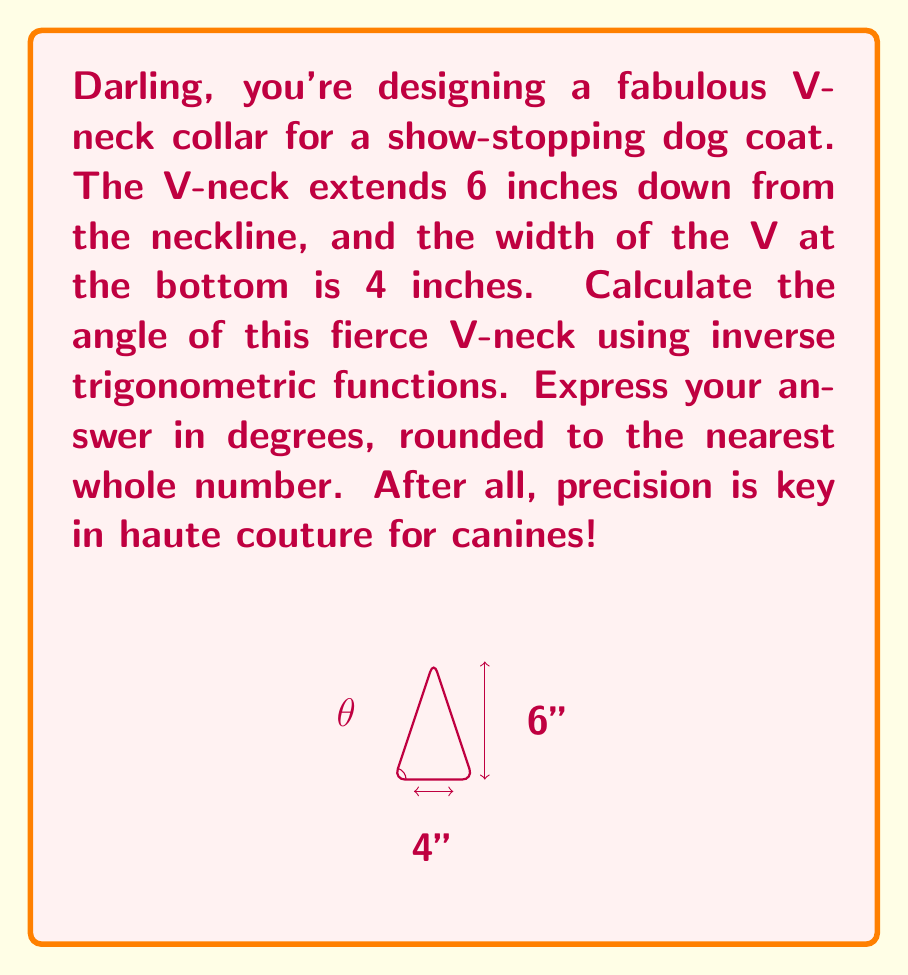Can you answer this question? Let's strut through this problem step by step, darling:

1) First, we need to identify the trigonometric function that relates the angle to the given dimensions. In this case, we're looking at half of the V-neck.

2) We can split the V-neck into two right triangles. Let's focus on one of them:
   - The opposite side is half the width of the V: 4/2 = 2 inches
   - The adjacent side is the length of the V: 6 inches

3) We're looking for the angle between these sides. The tangent function relates the opposite and adjacent sides:

   $$\tan(\theta) = \frac{\text{opposite}}{\text{adjacent}} = \frac{2}{6} = \frac{1}{3}$$

4) To find the angle, we need to use the inverse tangent function (arctan or $\tan^{-1}$):

   $$\theta = \tan^{-1}(\frac{1}{3})$$

5) Using a calculator (because even fashion designers need tech sometimes):

   $$\theta \approx 18.43494882292201^\circ$$

6) Rounding to the nearest whole number:

   $$\theta \approx 18^\circ$$

7) But wait! This is only half of the V-neck angle. For the full angle, we need to double this:

   $$\text{Full angle} = 2 \times 18^\circ = 36^\circ$$

And voilà! Our fabulously fierce V-neck is ready to dazzle the doggy runway!
Answer: $36^\circ$ 